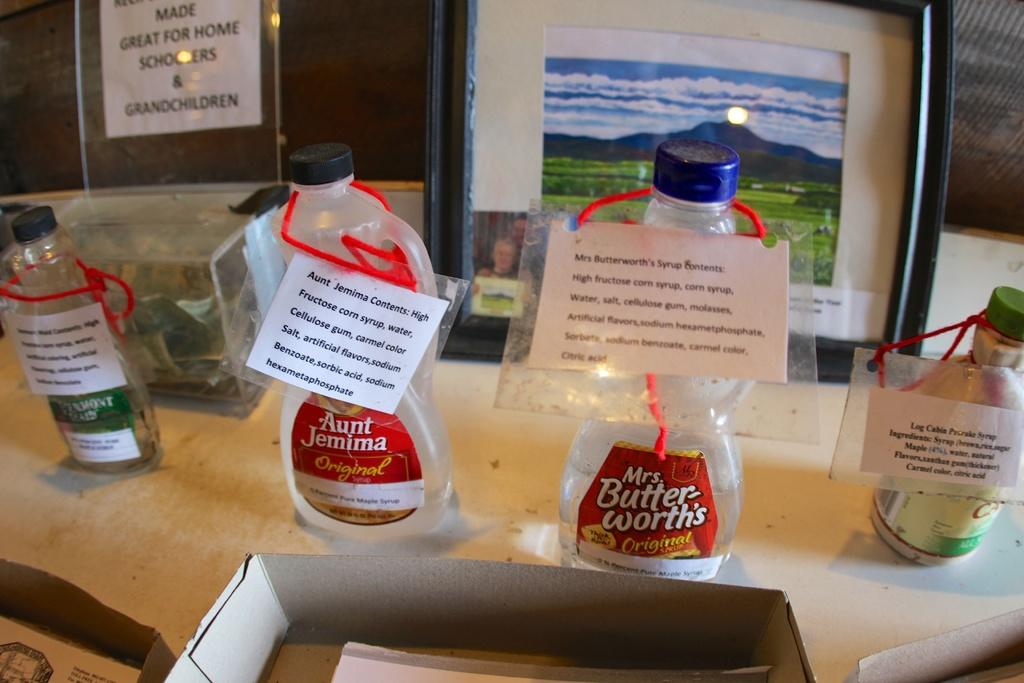Provide a one-sentence caption for the provided image. A row of Mrs Butter-worth's and Aunt Jemima syrup bottles are empty and have paper tags. 